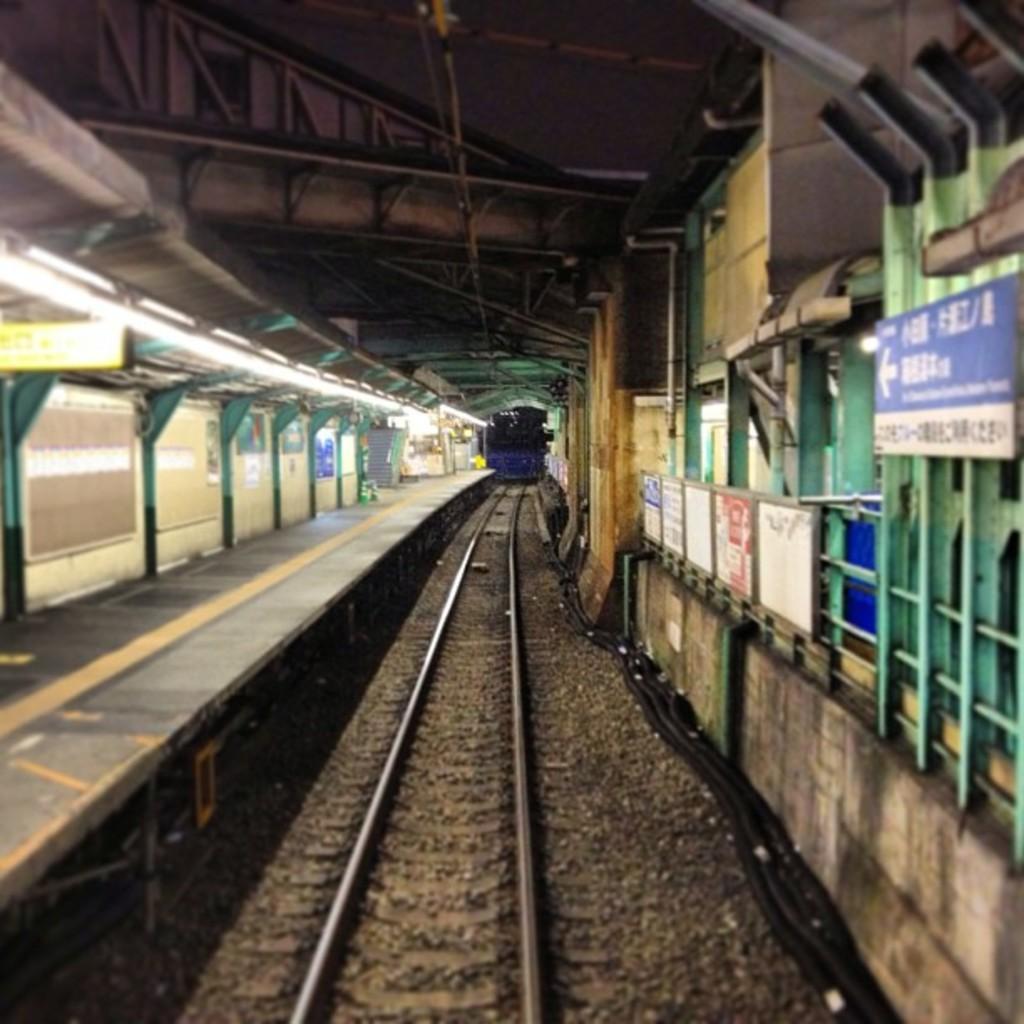Could you give a brief overview of what you see in this image? In this image there is a railway track , platform, lights, boards attached to the iron rods. 